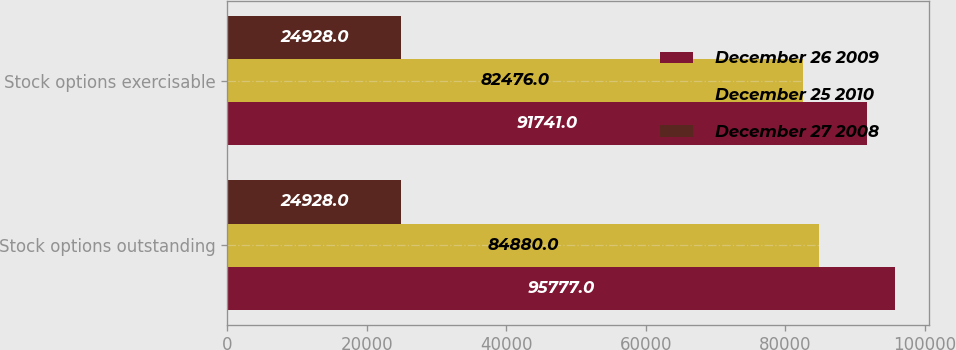<chart> <loc_0><loc_0><loc_500><loc_500><stacked_bar_chart><ecel><fcel>Stock options outstanding<fcel>Stock options exercisable<nl><fcel>December 26 2009<fcel>95777<fcel>91741<nl><fcel>December 25 2010<fcel>84880<fcel>82476<nl><fcel>December 27 2008<fcel>24928<fcel>24928<nl></chart> 